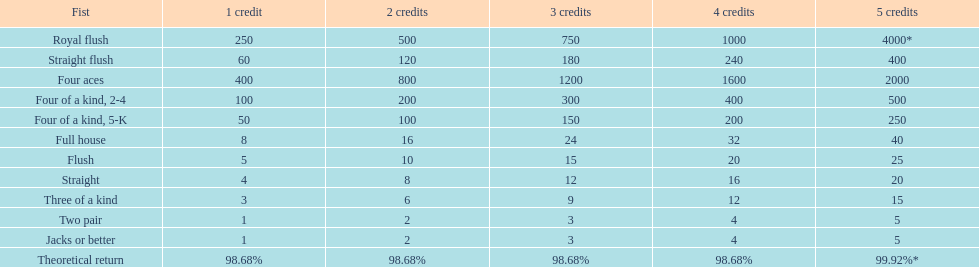What are the different hands? Royal flush, Straight flush, Four aces, Four of a kind, 2-4, Four of a kind, 5-K, Full house, Flush, Straight, Three of a kind, Two pair, Jacks or better. Which hands have a higher standing than a straight? Royal flush, Straight flush, Four aces, Four of a kind, 2-4, Four of a kind, 5-K, Full house, Flush. Of these, which hand is the next highest after a straight? Flush. 